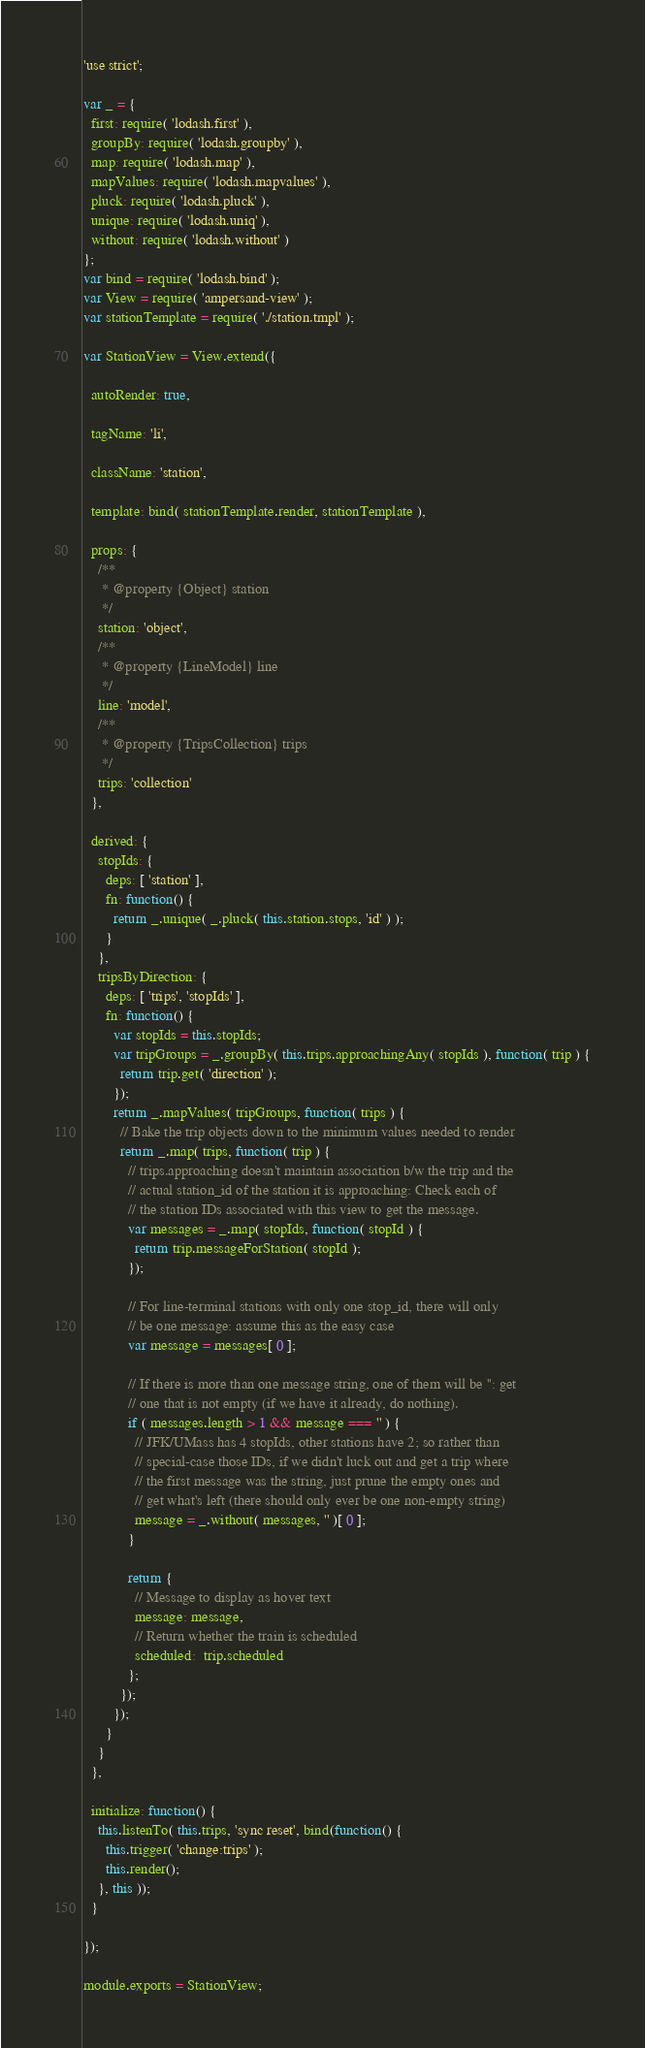Convert code to text. <code><loc_0><loc_0><loc_500><loc_500><_JavaScript_>'use strict';

var _ = {
  first: require( 'lodash.first' ),
  groupBy: require( 'lodash.groupby' ),
  map: require( 'lodash.map' ),
  mapValues: require( 'lodash.mapvalues' ),
  pluck: require( 'lodash.pluck' ),
  unique: require( 'lodash.uniq' ),
  without: require( 'lodash.without' )
};
var bind = require( 'lodash.bind' );
var View = require( 'ampersand-view' );
var stationTemplate = require( './station.tmpl' );

var StationView = View.extend({

  autoRender: true,

  tagName: 'li',

  className: 'station',

  template: bind( stationTemplate.render, stationTemplate ),

  props: {
    /**
     * @property {Object} station
     */
    station: 'object',
    /**
     * @property {LineModel} line
     */
    line: 'model',
    /**
     * @property {TripsCollection} trips
     */
    trips: 'collection'
  },

  derived: {
    stopIds: {
      deps: [ 'station' ],
      fn: function() {
        return _.unique( _.pluck( this.station.stops, 'id' ) );
      }
    },
    tripsByDirection: {
      deps: [ 'trips', 'stopIds' ],
      fn: function() {
        var stopIds = this.stopIds;
        var tripGroups = _.groupBy( this.trips.approachingAny( stopIds ), function( trip ) {
          return trip.get( 'direction' );
        });
        return _.mapValues( tripGroups, function( trips ) {
          // Bake the trip objects down to the minimum values needed to render
          return _.map( trips, function( trip ) {
            // trips.approaching doesn't maintain association b/w the trip and the
            // actual station_id of the station it is approaching: Check each of
            // the station IDs associated with this view to get the message.
            var messages = _.map( stopIds, function( stopId ) {
              return trip.messageForStation( stopId );
            });

            // For line-terminal stations with only one stop_id, there will only
            // be one message: assume this as the easy case
            var message = messages[ 0 ];

            // If there is more than one message string, one of them will be '': get
            // one that is not empty (if we have it already, do nothing).
            if ( messages.length > 1 && message === '' ) {
              // JFK/UMass has 4 stopIds, other stations have 2; so rather than
              // special-case those IDs, if we didn't luck out and get a trip where
              // the first message was the string, just prune the empty ones and
              // get what's left (there should only ever be one non-empty string)
              message = _.without( messages, '' )[ 0 ];
            }

            return {
              // Message to display as hover text
              message: message,
              // Return whether the train is scheduled
              scheduled:  trip.scheduled
            };
          });
        });
      }
    }
  },

  initialize: function() {
    this.listenTo( this.trips, 'sync reset', bind(function() {
      this.trigger( 'change:trips' );
      this.render();
    }, this ));
  }

});

module.exports = StationView;
</code> 